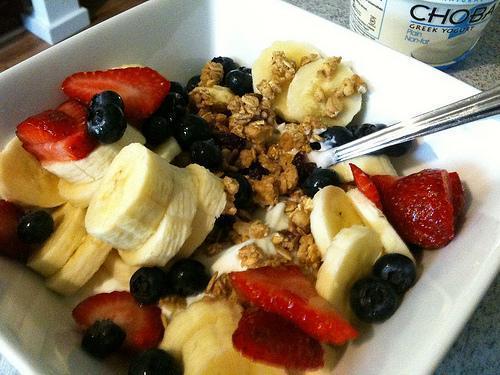How many different fruit are in here?
Give a very brief answer. 3. How many fruit are in the bowl?
Give a very brief answer. 3. 